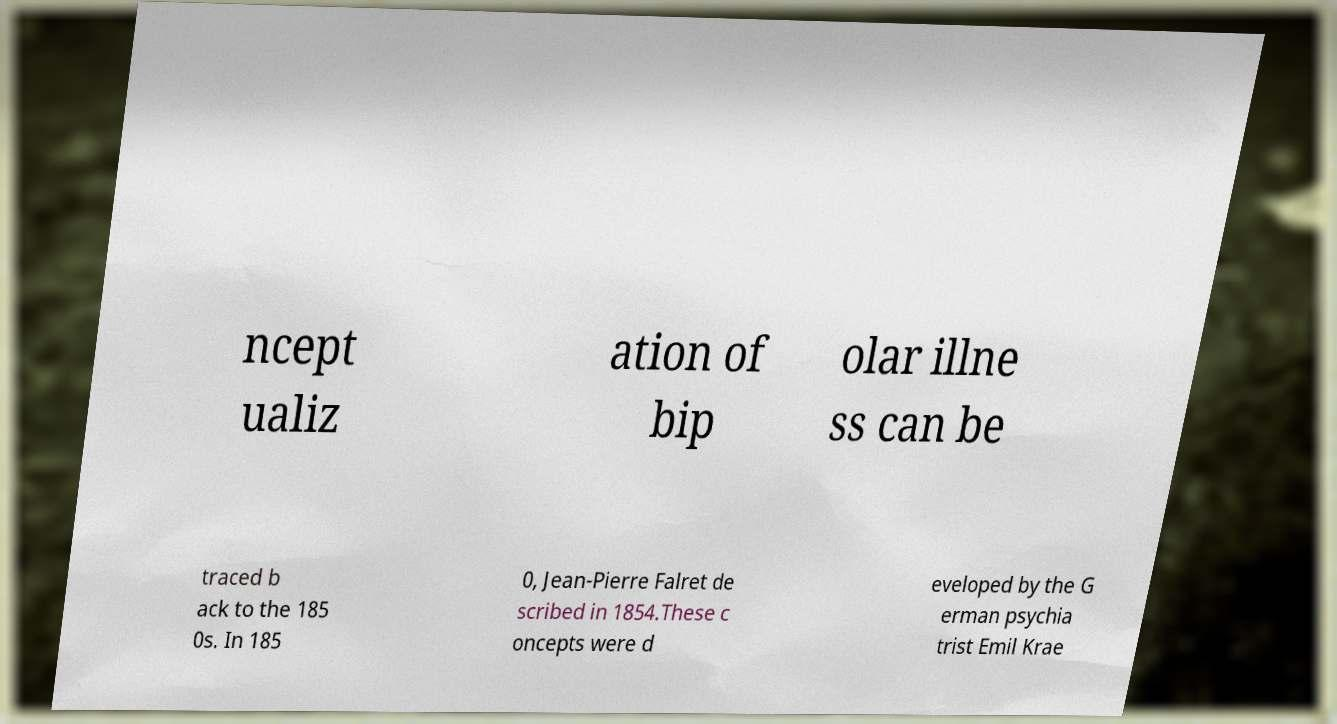There's text embedded in this image that I need extracted. Can you transcribe it verbatim? ncept ualiz ation of bip olar illne ss can be traced b ack to the 185 0s. In 185 0, Jean-Pierre Falret de scribed in 1854.These c oncepts were d eveloped by the G erman psychia trist Emil Krae 